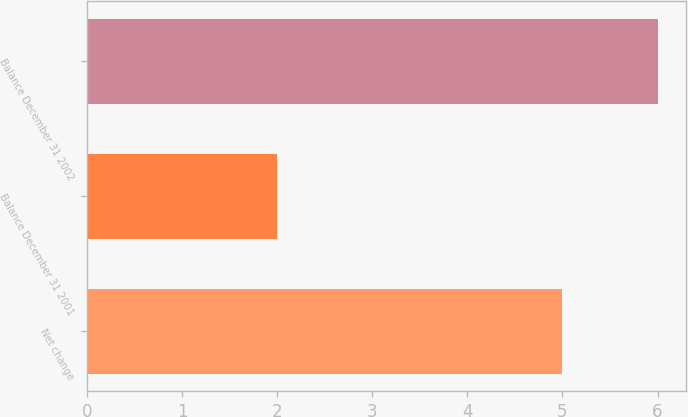Convert chart to OTSL. <chart><loc_0><loc_0><loc_500><loc_500><bar_chart><fcel>Net change<fcel>Balance December 31 2001<fcel>Balance December 31 2002<nl><fcel>5<fcel>2<fcel>6<nl></chart> 